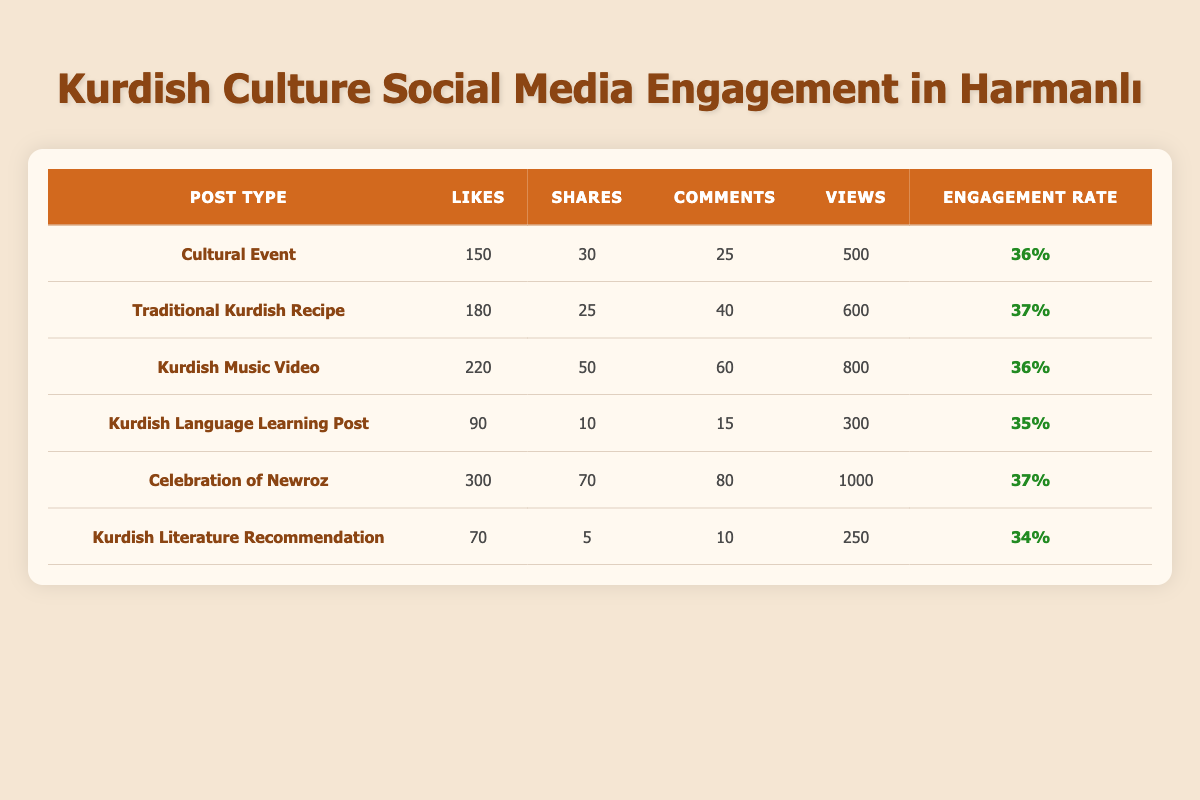What post type received the highest number of likes? The max likes can be identified by comparing the 'likes' column across all post types. The "Celebration of Newroz" has 300 likes, which is greater than any other post type's likes.
Answer: Celebration of Newroz What is the total number of comments across all posts? To find the total number of comments, sum the comments from each post type: 25 + 40 + 60 + 15 + 80 + 10 = 230.
Answer: 230 Is the engagement rate for "Kurdish Literature Recommendation" higher than for "Kurdish Language Learning Post"? The engagement rate for "Kurdish Literature Recommendation" is 34%, while for "Kurdish Language Learning Post" it is 35%. Thus, it is not higher.
Answer: No Which post type has the lowest engagement rate? By examining the engagement rate column, it can be seen that "Kurdish Literature Recommendation" has the lowest engagement rate at 34%.
Answer: Kurdish Literature Recommendation What is the average number of shares for all the posts? To find the average, add all shares: 30 + 25 + 50 + 10 + 70 + 5 = 190, and divide by the number of posts (6). So, 190/6 = approximately 31.67.
Answer: Approximately 31.67 How many views does the "Kurdish Music Video" post have compared to the average number of views for all posts? The "Kurdish Music Video" has 800 views. First, calculate the total views: 500 + 600 + 800 + 300 + 1000 + 250 = 3450, then find the average views by dividing 3450 by 6 (averaging to 575). Since 800 > 575, it has more views than average.
Answer: More views Are there more likes for "Cultural Event" or "Traditional Kurdish Recipe"? Compare their likes: "Cultural Event" has 150 likes and "Traditional Kurdish Recipe" has 180 likes. Since 180 > 150, "Traditional Kurdish Recipe" has more likes.
Answer: Traditional Kurdish Recipe What is the difference in views between the "Celebration of Newroz" and the "Kurdish Literature Recommendation"? Calculate the views for both: "Celebration of Newroz" has 1000 views and "Kurdish Literature Recommendation" has 250 views. The difference is 1000 - 250 = 750.
Answer: 750 